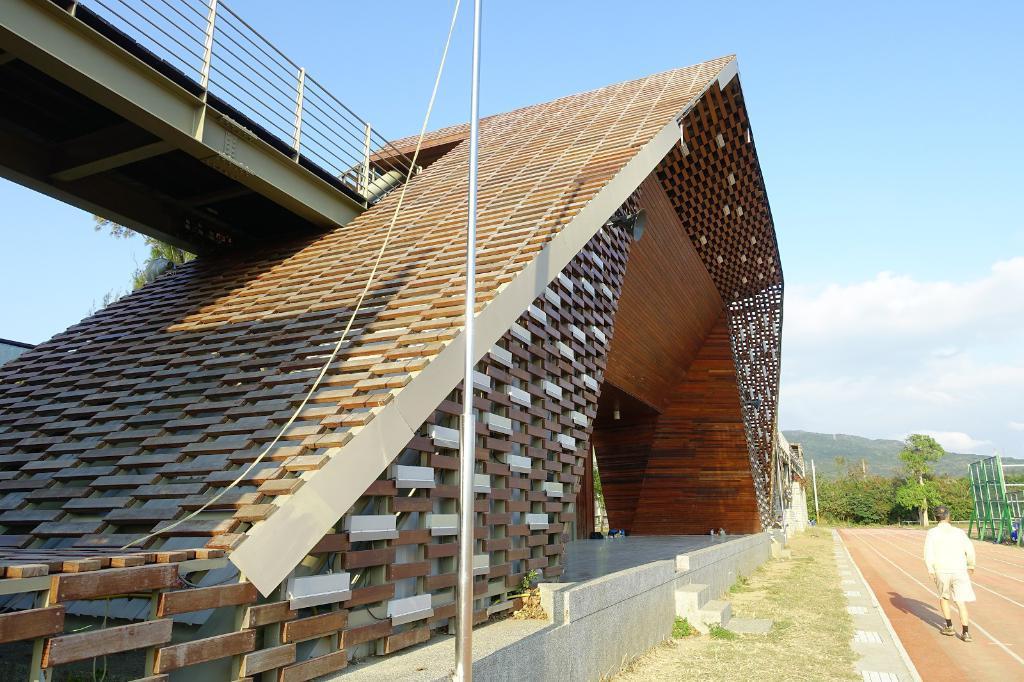Describe this image in one or two sentences. In this image we can able to see a person walking on the way, there is a bridge beside to him, we can see some trees, mountains, there is a pole and a rope, we can see the sky. 